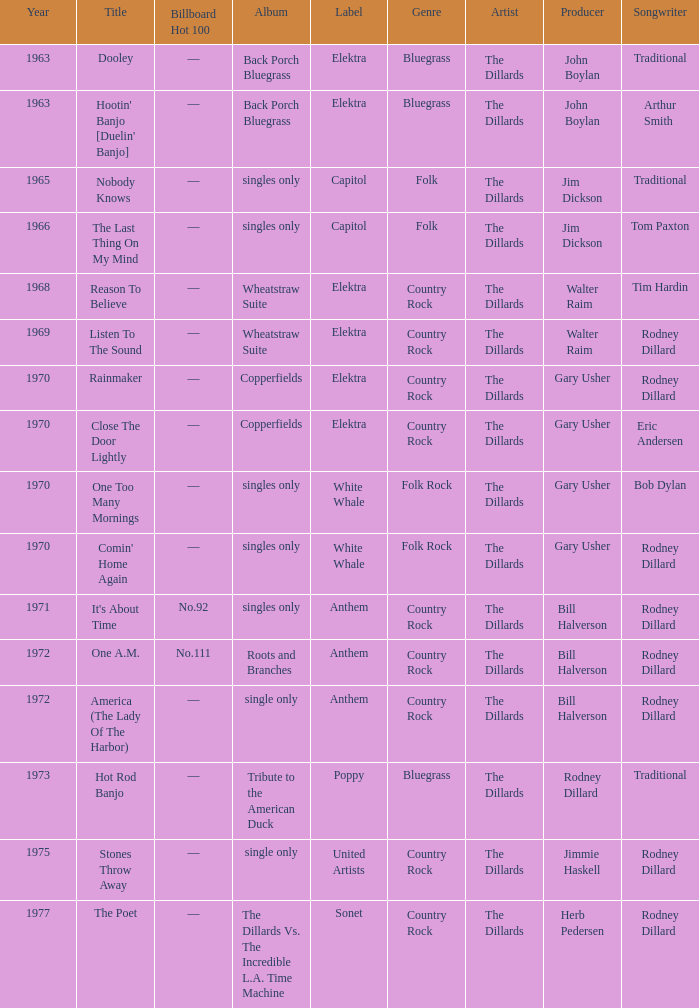Could you parse the entire table as a dict? {'header': ['Year', 'Title', 'Billboard Hot 100', 'Album', 'Label', 'Genre', 'Artist', 'Producer', 'Songwriter'], 'rows': [['1963', 'Dooley', '—', 'Back Porch Bluegrass', 'Elektra', 'Bluegrass', 'The Dillards', 'John Boylan', 'Traditional'], ['1963', "Hootin' Banjo [Duelin' Banjo]", '—', 'Back Porch Bluegrass', 'Elektra', 'Bluegrass', 'The Dillards', 'John Boylan', 'Arthur Smith'], ['1965', 'Nobody Knows', '—', 'singles only', 'Capitol', 'Folk', 'The Dillards', 'Jim Dickson', 'Traditional'], ['1966', 'The Last Thing On My Mind', '—', 'singles only', 'Capitol', 'Folk', 'The Dillards', 'Jim Dickson', 'Tom Paxton'], ['1968', 'Reason To Believe', '—', 'Wheatstraw Suite', 'Elektra', 'Country Rock', 'The Dillards', 'Walter Raim', 'Tim Hardin'], ['1969', 'Listen To The Sound', '—', 'Wheatstraw Suite', 'Elektra', 'Country Rock', 'The Dillards', 'Walter Raim', 'Rodney Dillard'], ['1970', 'Rainmaker', '—', 'Copperfields', 'Elektra', 'Country Rock', 'The Dillards', 'Gary Usher', 'Rodney Dillard'], ['1970', 'Close The Door Lightly', '—', 'Copperfields', 'Elektra', 'Country Rock', 'The Dillards', 'Gary Usher', 'Eric Andersen'], ['1970', 'One Too Many Mornings', '—', 'singles only', 'White Whale', 'Folk Rock', 'The Dillards', 'Gary Usher', 'Bob Dylan'], ['1970', "Comin' Home Again", '—', 'singles only', 'White Whale', 'Folk Rock', 'The Dillards', 'Gary Usher', 'Rodney Dillard'], ['1971', "It's About Time", 'No.92', 'singles only', 'Anthem', 'Country Rock', 'The Dillards', 'Bill Halverson', 'Rodney Dillard'], ['1972', 'One A.M.', 'No.111', 'Roots and Branches', 'Anthem', 'Country Rock', 'The Dillards', 'Bill Halverson', 'Rodney Dillard'], ['1972', 'America (The Lady Of The Harbor)', '—', 'single only', 'Anthem', 'Country Rock', 'The Dillards', 'Bill Halverson', 'Rodney Dillard'], ['1973', 'Hot Rod Banjo', '—', 'Tribute to the American Duck', 'Poppy', 'Bluegrass', 'The Dillards', 'Rodney Dillard', 'Traditional'], ['1975', 'Stones Throw Away', '—', 'single only', 'United Artists', 'Country Rock', 'The Dillards', 'Jimmie Haskell', 'Rodney Dillard'], ['1977', 'The Poet', '—', 'The Dillards Vs. The Incredible L.A. Time Machine', 'Sonet', 'Country Rock', 'The Dillards', 'Herb Pedersen', 'Rodney Dillard']]} What is the complete period for roots and branches? 1972.0. 